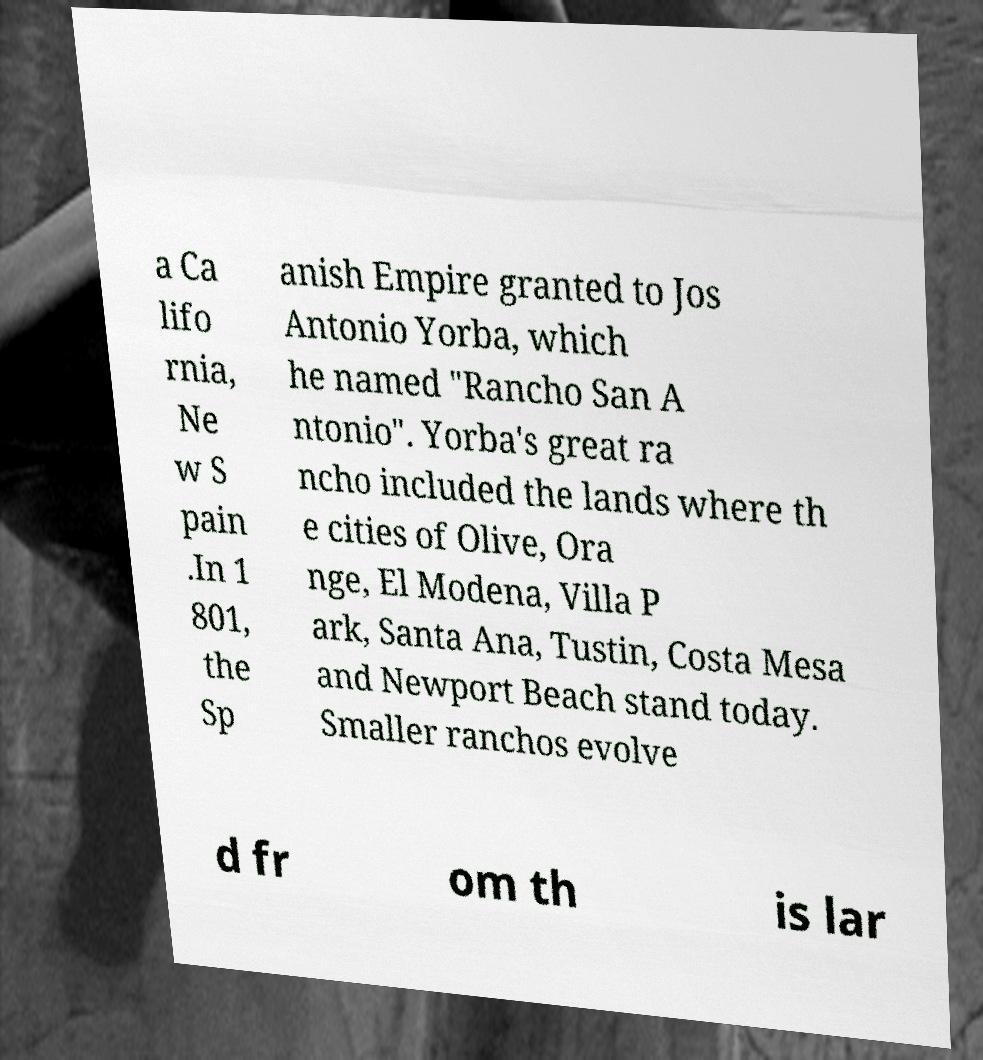Please identify and transcribe the text found in this image. a Ca lifo rnia, Ne w S pain .In 1 801, the Sp anish Empire granted to Jos Antonio Yorba, which he named "Rancho San A ntonio". Yorba's great ra ncho included the lands where th e cities of Olive, Ora nge, El Modena, Villa P ark, Santa Ana, Tustin, Costa Mesa and Newport Beach stand today. Smaller ranchos evolve d fr om th is lar 